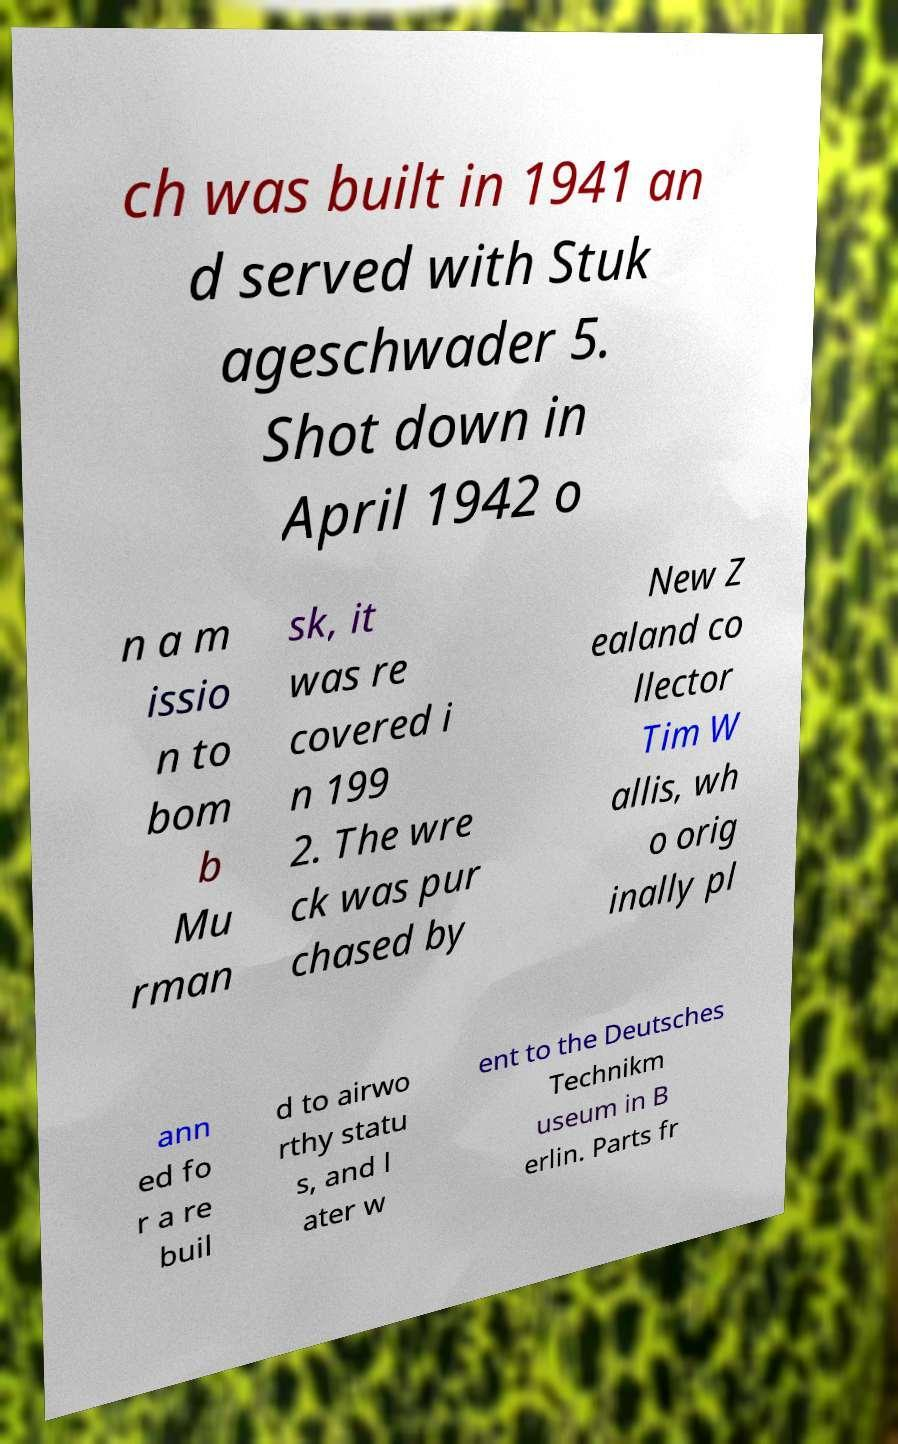For documentation purposes, I need the text within this image transcribed. Could you provide that? ch was built in 1941 an d served with Stuk ageschwader 5. Shot down in April 1942 o n a m issio n to bom b Mu rman sk, it was re covered i n 199 2. The wre ck was pur chased by New Z ealand co llector Tim W allis, wh o orig inally pl ann ed fo r a re buil d to airwo rthy statu s, and l ater w ent to the Deutsches Technikm useum in B erlin. Parts fr 